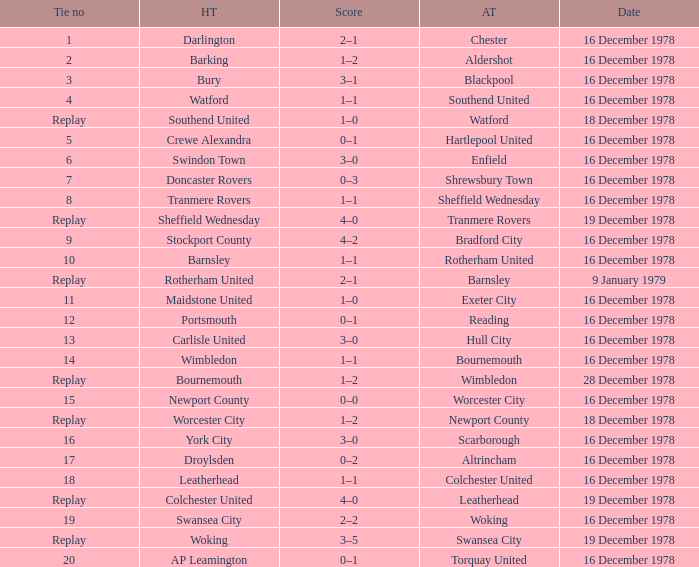What is the tie no for the home team swansea city? 19.0. 